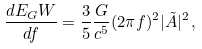Convert formula to latex. <formula><loc_0><loc_0><loc_500><loc_500>\frac { d E _ { G } W } { d f } = \frac { 3 } { 5 } \frac { G } { c ^ { 5 } } ( 2 \pi f ) ^ { 2 } | \tilde { A } | ^ { 2 } \, ,</formula> 